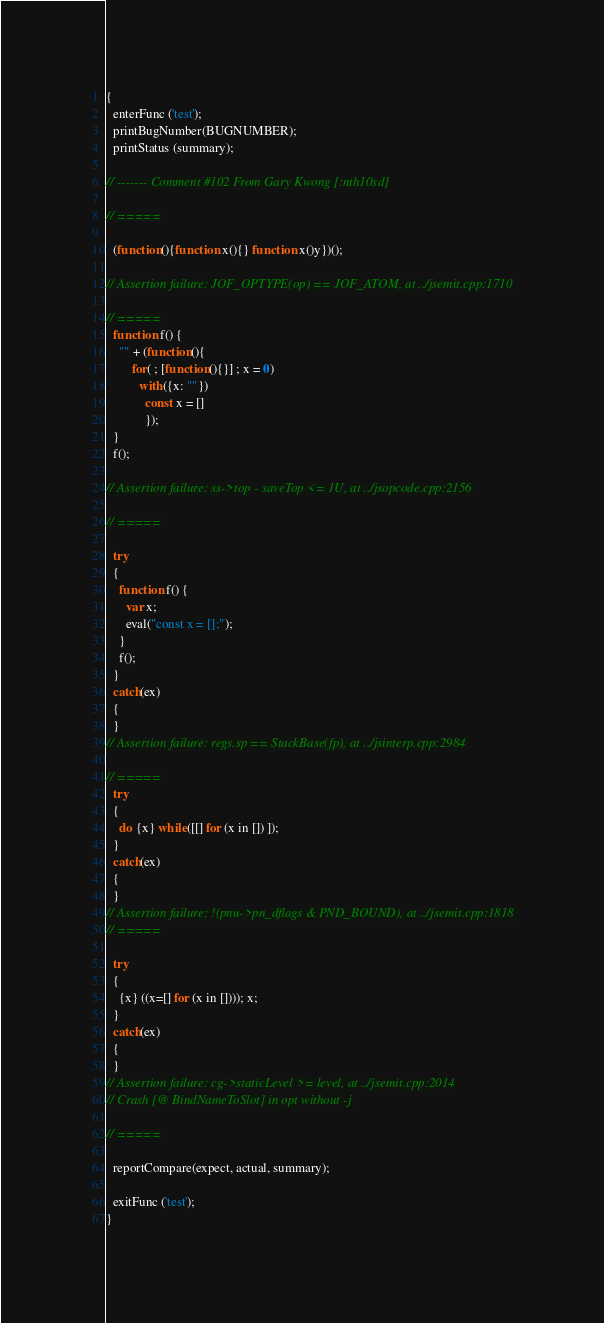<code> <loc_0><loc_0><loc_500><loc_500><_JavaScript_>{
  enterFunc ('test');
  printBugNumber(BUGNUMBER);
  printStatus (summary);
 
// ------- Comment #102 From Gary Kwong [:nth10sd]

// =====

  (function(){function x(){} function x()y})();

// Assertion failure: JOF_OPTYPE(op) == JOF_ATOM, at ../jsemit.cpp:1710

// =====
  function f() {
    "" + (function(){
        for( ; [function(){}] ; x = 0)
          with({x: ""})
            const x = []
            });
  }
  f();

// Assertion failure: ss->top - saveTop <= 1U, at ../jsopcode.cpp:2156

// =====

  try
  {
    function f() {
      var x;
      eval("const x = [];");
    }
    f();
  }
  catch(ex)
  {
  }
// Assertion failure: regs.sp == StackBase(fp), at ../jsinterp.cpp:2984

// =====
  try
  {
    do {x} while([[] for (x in []) ]);
  }
  catch(ex)
  {
  }
// Assertion failure: !(pnu->pn_dflags & PND_BOUND), at ../jsemit.cpp:1818
// =====

  try
  {
    {x} ((x=[] for (x in []))); x;
  }
  catch(ex)
  {
  }
// Assertion failure: cg->staticLevel >= level, at ../jsemit.cpp:2014
// Crash [@ BindNameToSlot] in opt without -j

// =====

  reportCompare(expect, actual, summary);

  exitFunc ('test');
}



</code> 